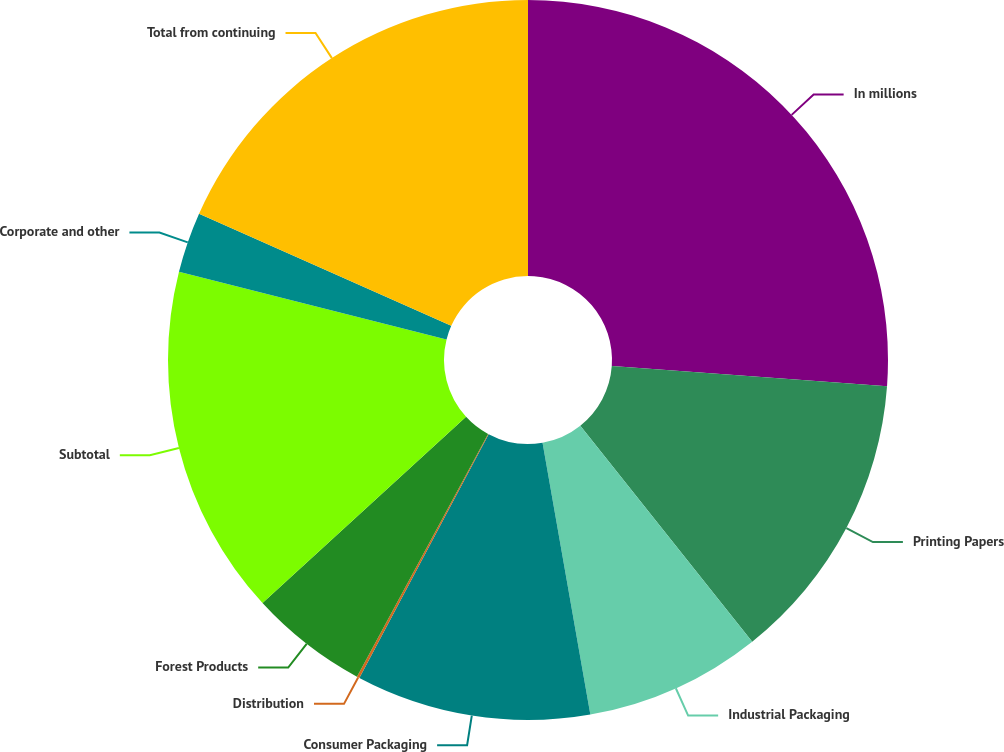Convert chart. <chart><loc_0><loc_0><loc_500><loc_500><pie_chart><fcel>In millions<fcel>Printing Papers<fcel>Industrial Packaging<fcel>Consumer Packaging<fcel>Distribution<fcel>Forest Products<fcel>Subtotal<fcel>Corporate and other<fcel>Total from continuing<nl><fcel>26.16%<fcel>13.14%<fcel>7.93%<fcel>10.53%<fcel>0.12%<fcel>5.32%<fcel>15.74%<fcel>2.72%<fcel>18.34%<nl></chart> 